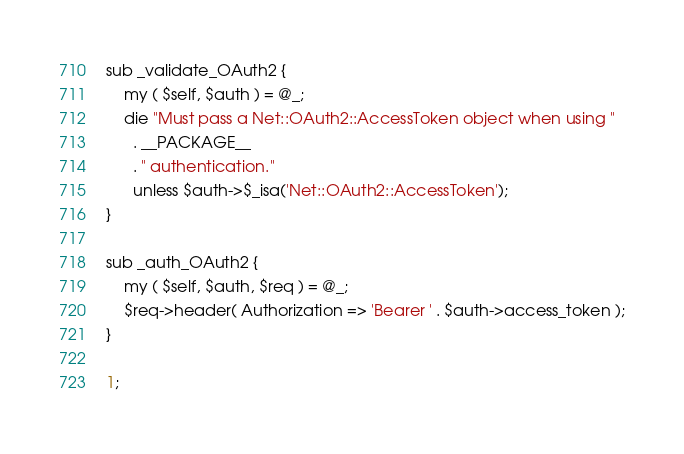Convert code to text. <code><loc_0><loc_0><loc_500><loc_500><_Perl_>
sub _validate_OAuth2 {
    my ( $self, $auth ) = @_;
    die "Must pass a Net::OAuth2::AccessToken object when using "
      . __PACKAGE__
      . " authentication."
      unless $auth->$_isa('Net::OAuth2::AccessToken');
}

sub _auth_OAuth2 {
    my ( $self, $auth, $req ) = @_;
    $req->header( Authorization => 'Bearer ' . $auth->access_token );
}

1;
</code> 